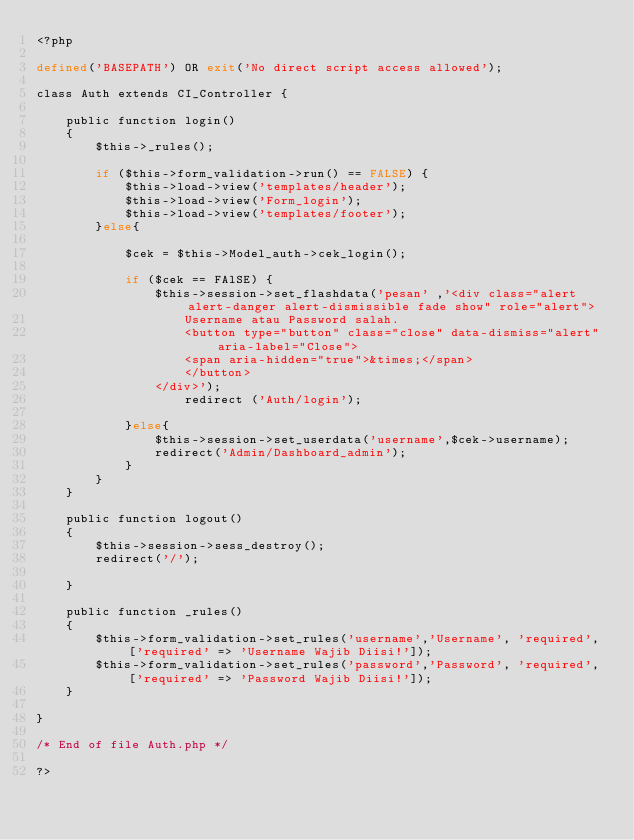<code> <loc_0><loc_0><loc_500><loc_500><_PHP_><?php

defined('BASEPATH') OR exit('No direct script access allowed');

class Auth extends CI_Controller {

    public function login()
    {
        $this->_rules();

        if ($this->form_validation->run() == FALSE) {
            $this->load->view('templates/header');
            $this->load->view('Form_login');
            $this->load->view('templates/footer');
        }else{

            $cek = $this->Model_auth->cek_login();

            if ($cek == FAlSE) {
                $this->session->set_flashdata('pesan' ,'<div class="alert alert-danger alert-dismissible fade show" role="alert">
                    Username atau Password salah.
                    <button type="button" class="close" data-dismiss="alert" aria-label="Close">
                    <span aria-hidden="true">&times;</span>
                    </button>
                </div>');
                    redirect ('Auth/login');
                
            }else{
                $this->session->set_userdata('username',$cek->username);
                redirect('Admin/Dashboard_admin');
            }
        }
    }

    public function logout()
    {
        $this->session->sess_destroy();
        redirect('/');
        
    }

    public function _rules()
    {
        $this->form_validation->set_rules('username','Username', 'required', ['required' => 'Username Wajib Diisi!']);
        $this->form_validation->set_rules('password','Password', 'required', ['required' => 'Password Wajib Diisi!']);
    }

}

/* End of file Auth.php */

?></code> 